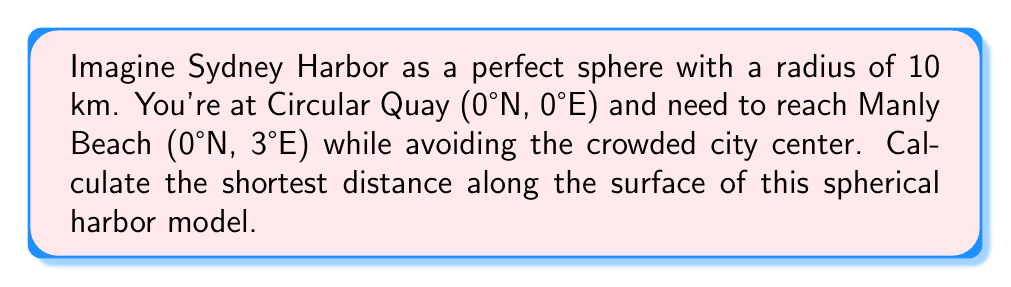Could you help me with this problem? To solve this problem, we'll use the great circle distance formula on a sphere:

1) The great circle distance formula is:
   $$d = R \cdot \arccos(\sin\phi_1 \sin\phi_2 + \cos\phi_1 \cos\phi_2 \cos|\lambda_1 - \lambda_2|)$$
   where $R$ is the radius, $\phi$ is latitude, and $\lambda$ is longitude.

2) Given:
   - Radius $R = 10$ km
   - Circular Quay: $\phi_1 = 0°$, $\lambda_1 = 0°$
   - Manly Beach: $\phi_2 = 0°$, $\lambda_2 = 3°$

3) Simplify the formula since both latitudes are 0°:
   $$d = R \cdot \arccos(\cos|\lambda_1 - \lambda_2|)$$

4) Calculate the longitude difference:
   $|\lambda_1 - \lambda_2| = |0° - 3°| = 3°$

5) Convert 3° to radians:
   $3° \cdot \frac{\pi}{180°} = 0.0524$ radians

6) Plug into the formula:
   $$d = 10 \cdot \arccos(\cos(0.0524))$$

7) Calculate:
   $$d = 10 \cdot 0.0524 = 0.524$$ km

Therefore, the shortest distance along the surface is approximately 0.524 km.

[asy]
import geometry;

size(200);
pair O=(0,0);
real R=5;
draw(circle(O,R));
pair A=(R,0);
pair B=rotate(17.2)*A;
draw(A--O--B);
draw(Arc(O,A,B),blue);
label("Circular Quay",A,E);
label("Manly Beach",B,E);
label("0.524 km",0.5*(A+B),NW,blue);
[/asy]
Answer: 0.524 km 